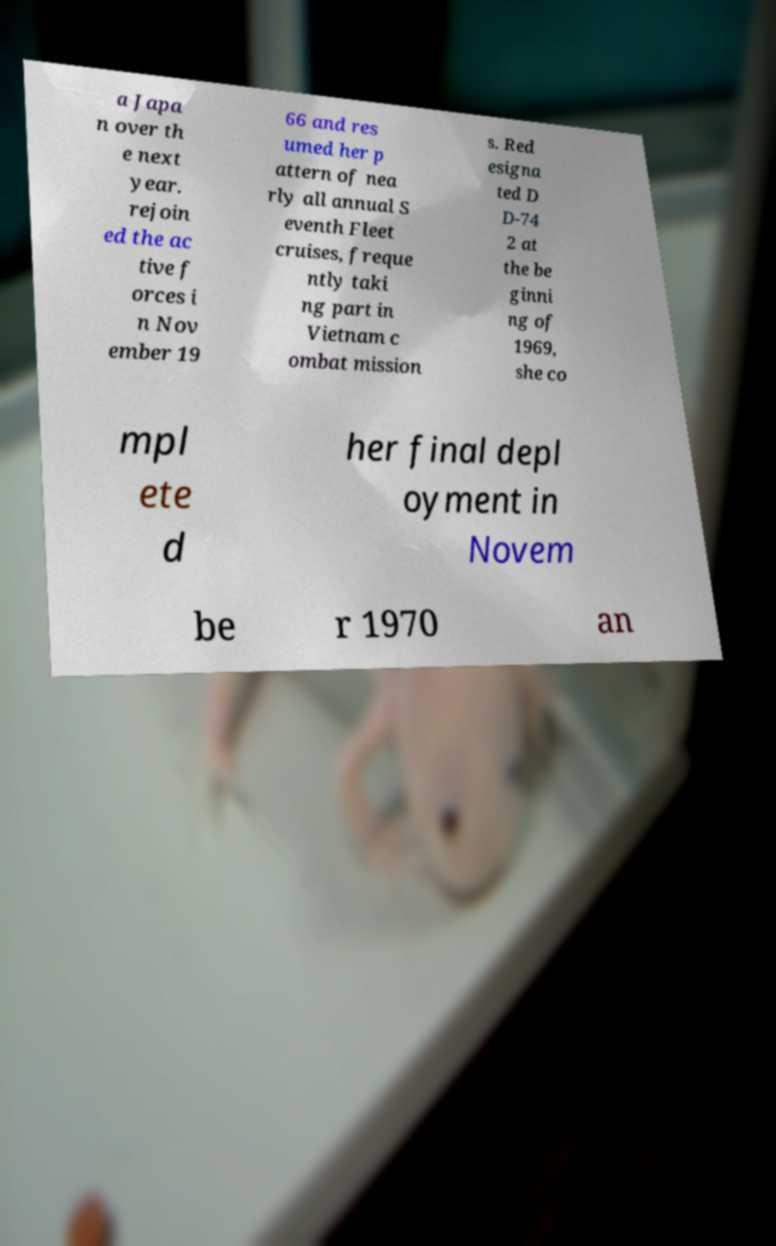Please identify and transcribe the text found in this image. a Japa n over th e next year. rejoin ed the ac tive f orces i n Nov ember 19 66 and res umed her p attern of nea rly all annual S eventh Fleet cruises, freque ntly taki ng part in Vietnam c ombat mission s. Red esigna ted D D-74 2 at the be ginni ng of 1969, she co mpl ete d her final depl oyment in Novem be r 1970 an 